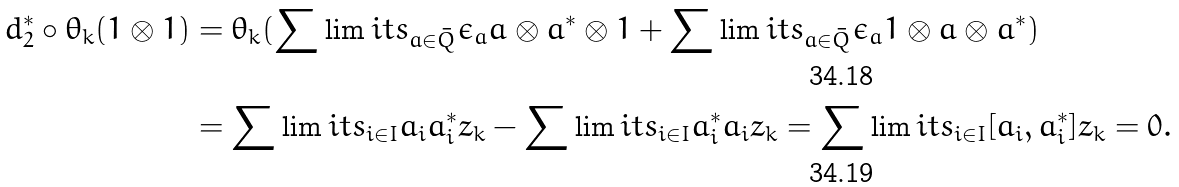Convert formula to latex. <formula><loc_0><loc_0><loc_500><loc_500>d _ { 2 } ^ { * } \circ \theta _ { k } ( 1 \otimes 1 ) & = \theta _ { k } ( \sum \lim i t s _ { a \in \bar { Q } } \epsilon _ { a } a \otimes a ^ { * } \otimes 1 + \sum \lim i t s _ { a \in \bar { Q } } \epsilon _ { a } 1 \otimes a \otimes a ^ { * } ) \\ & = \sum \lim i t s _ { i \in I } a _ { i } a _ { i } ^ { * } z _ { k } - \sum \lim i t s _ { i \in I } a _ { i } ^ { * } a _ { i } z _ { k } = \sum \lim i t s _ { i \in I } [ a _ { i } , a _ { i } ^ { * } ] z _ { k } = 0 .</formula> 